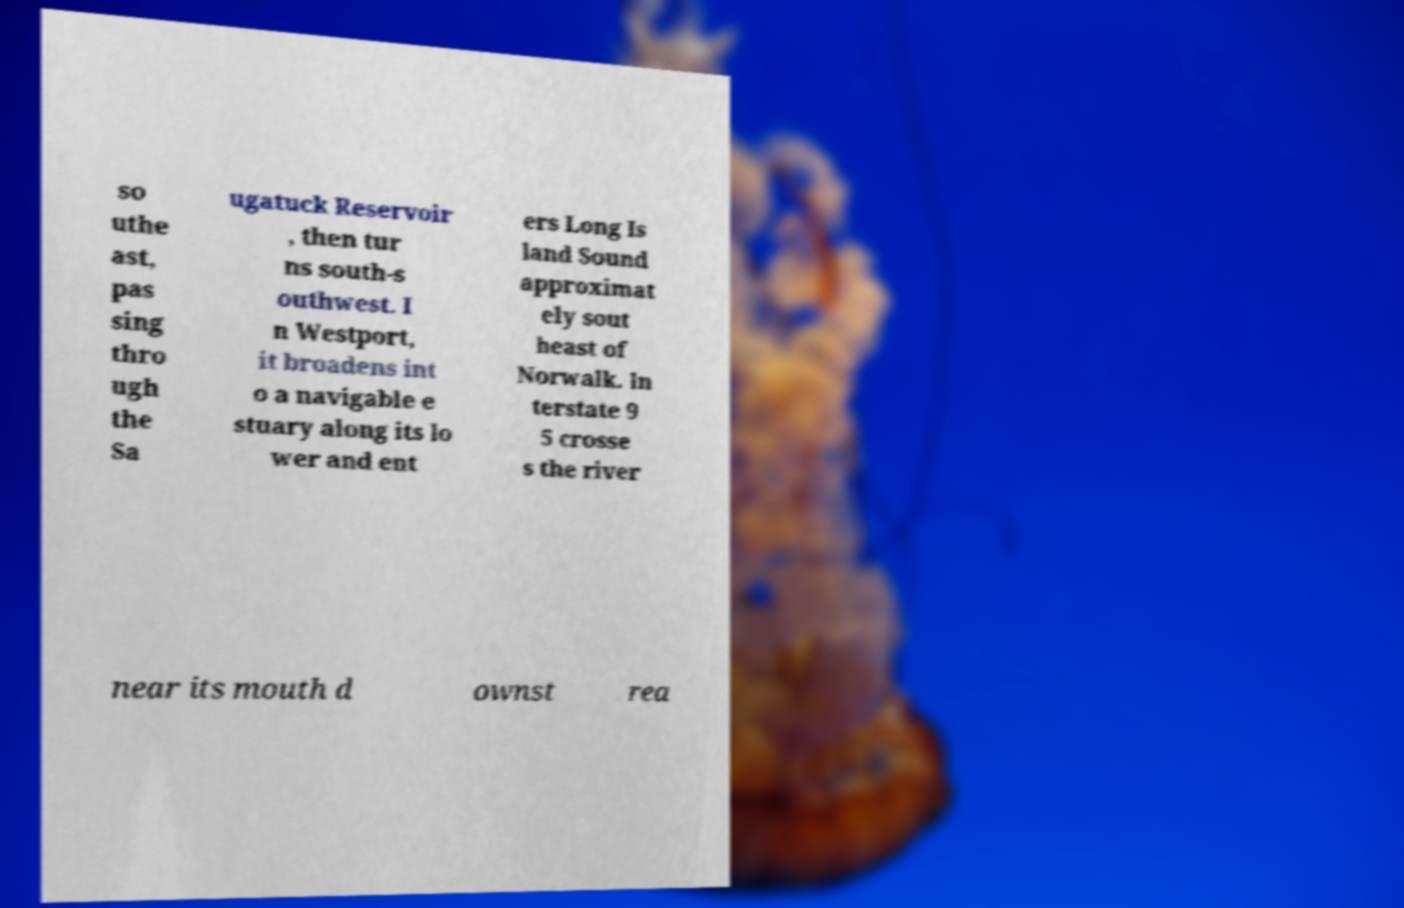Could you extract and type out the text from this image? so uthe ast, pas sing thro ugh the Sa ugatuck Reservoir , then tur ns south-s outhwest. I n Westport, it broadens int o a navigable e stuary along its lo wer and ent ers Long Is land Sound approximat ely sout heast of Norwalk. In terstate 9 5 crosse s the river near its mouth d ownst rea 